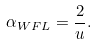<formula> <loc_0><loc_0><loc_500><loc_500>\alpha _ { W F L } = \frac { 2 } { u } .</formula> 